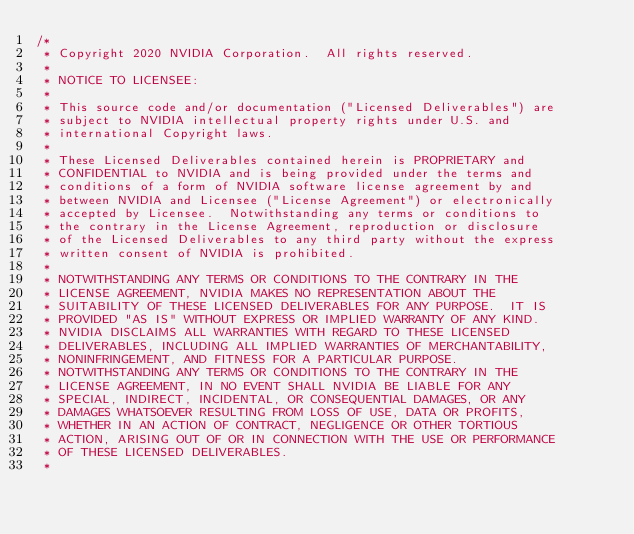Convert code to text. <code><loc_0><loc_0><loc_500><loc_500><_Cuda_>/*
 * Copyright 2020 NVIDIA Corporation.  All rights reserved.
 *
 * NOTICE TO LICENSEE:
 *
 * This source code and/or documentation ("Licensed Deliverables") are
 * subject to NVIDIA intellectual property rights under U.S. and
 * international Copyright laws.
 *
 * These Licensed Deliverables contained herein is PROPRIETARY and
 * CONFIDENTIAL to NVIDIA and is being provided under the terms and
 * conditions of a form of NVIDIA software license agreement by and
 * between NVIDIA and Licensee ("License Agreement") or electronically
 * accepted by Licensee.  Notwithstanding any terms or conditions to
 * the contrary in the License Agreement, reproduction or disclosure
 * of the Licensed Deliverables to any third party without the express
 * written consent of NVIDIA is prohibited.
 *
 * NOTWITHSTANDING ANY TERMS OR CONDITIONS TO THE CONTRARY IN THE
 * LICENSE AGREEMENT, NVIDIA MAKES NO REPRESENTATION ABOUT THE
 * SUITABILITY OF THESE LICENSED DELIVERABLES FOR ANY PURPOSE.  IT IS
 * PROVIDED "AS IS" WITHOUT EXPRESS OR IMPLIED WARRANTY OF ANY KIND.
 * NVIDIA DISCLAIMS ALL WARRANTIES WITH REGARD TO THESE LICENSED
 * DELIVERABLES, INCLUDING ALL IMPLIED WARRANTIES OF MERCHANTABILITY,
 * NONINFRINGEMENT, AND FITNESS FOR A PARTICULAR PURPOSE.
 * NOTWITHSTANDING ANY TERMS OR CONDITIONS TO THE CONTRARY IN THE
 * LICENSE AGREEMENT, IN NO EVENT SHALL NVIDIA BE LIABLE FOR ANY
 * SPECIAL, INDIRECT, INCIDENTAL, OR CONSEQUENTIAL DAMAGES, OR ANY
 * DAMAGES WHATSOEVER RESULTING FROM LOSS OF USE, DATA OR PROFITS,
 * WHETHER IN AN ACTION OF CONTRACT, NEGLIGENCE OR OTHER TORTIOUS
 * ACTION, ARISING OUT OF OR IN CONNECTION WITH THE USE OR PERFORMANCE
 * OF THESE LICENSED DELIVERABLES.
 *</code> 